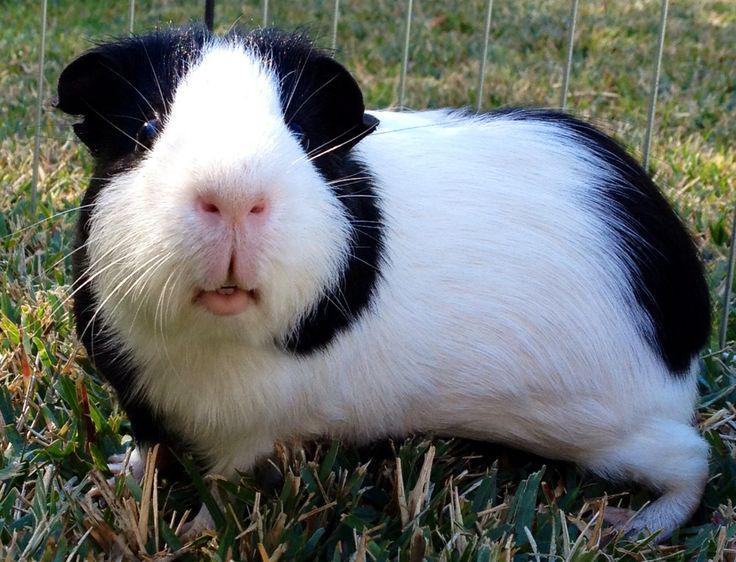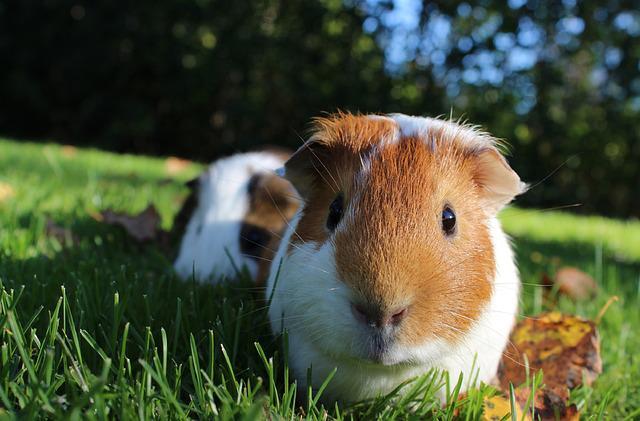The first image is the image on the left, the second image is the image on the right. Considering the images on both sides, is "At least one of the images is of a single guinea pig laying in the grass." valid? Answer yes or no. Yes. The first image is the image on the left, the second image is the image on the right. Assess this claim about the two images: "The guinea pig is sitting on the grass.". Correct or not? Answer yes or no. Yes. 